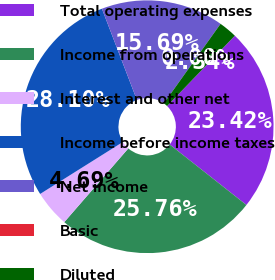<chart> <loc_0><loc_0><loc_500><loc_500><pie_chart><fcel>Total operating expenses<fcel>Income from operations<fcel>Interest and other net<fcel>Income before income taxes<fcel>Net income<fcel>Basic<fcel>Diluted<nl><fcel>23.42%<fcel>25.76%<fcel>4.69%<fcel>28.1%<fcel>15.69%<fcel>0.0%<fcel>2.34%<nl></chart> 